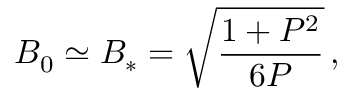Convert formula to latex. <formula><loc_0><loc_0><loc_500><loc_500>B _ { 0 } \simeq B _ { * } = \sqrt { \frac { 1 + P ^ { 2 } } { 6 P } } \, ,</formula> 